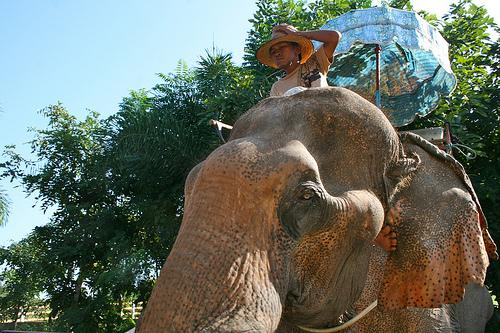Question: where was the picture taken?
Choices:
A. On an elephant ride.
B. At the horse race.
C. At the zoo.
D. At the beach.
Answer with the letter. Answer: A Question: who is on the elephant?
Choices:
A. The woman.
B. The boy.
C. The man.
D. The girl.
Answer with the letter. Answer: C Question: what is behind the elephant?
Choices:
A. The tree.
B. The bush.
C. The lake.
D. The grass.
Answer with the letter. Answer: A 